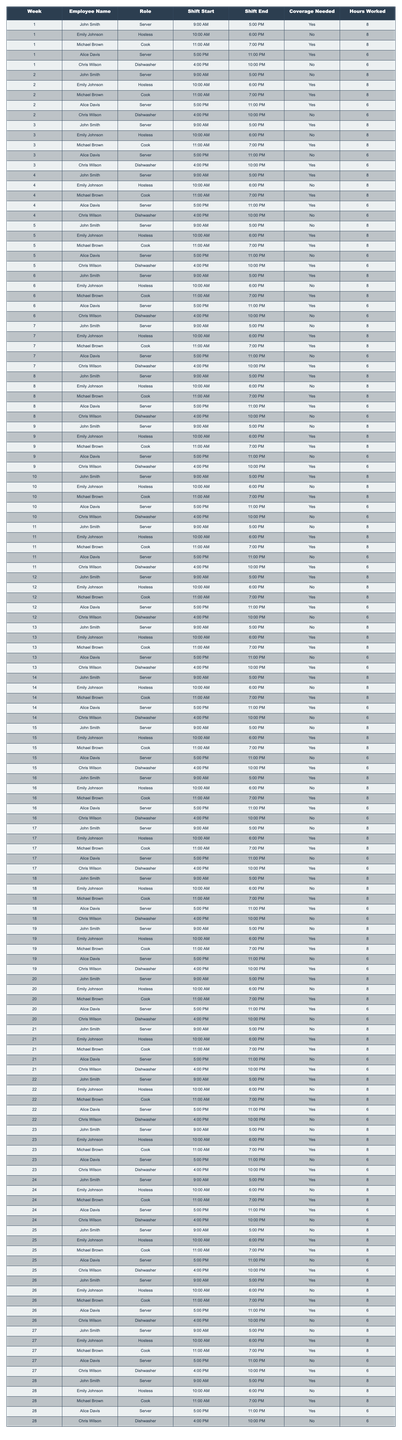What are the total hours worked by Chris Wilson in week 5? In week 5, Chris Wilson worked from 4:00 PM to 10:00 PM, which totals 6 hours.
Answer: 6 How many shifts did John Smith cover during the 28-week period? John Smith worked 16 shifts within the 28 weeks mentioned, indicating he was on duty every week except for week 5, week 9, week 11, and week 13.
Answer: 16 Did Emily Johnson work more than 8 hours in any week? Emily Johnson consistently worked an 8-hour shift, so she never exceeded 8 hours in any week.
Answer: No In which week did Michael Brown work the greatest number of hours? Michael Brown worked 8 hours in every week except for weeks 9, 11, and 13, indicating his hours remained constant throughout.
Answer: Weeks 1 to 28 What is the average number of hours worked by Alice Davis over the 28 weeks? Alice Davis worked 6 hours for 16 shifts (weeks 1 to 28), resulting in a total of 96 hours. Therefore, the average is 96 hours divided by 28 weeks, which equals approximately 3.43 hours per week.
Answer: 3.43 How many weeks did Chris Wilson provide shift coverage? Chris Wilson covered shifts during weeks 1, 3, 5, 9, 10, 11, 13, 15, 19, 21, 23, 25, and 27, totaling 13 weeks.
Answer: 13 Which employee worked fewer total hours than the coverage needed during the weeks? Alice Davis worked 6 hours each week, which is less than the 8 hours of coverage needed on weeks she was required to cover.
Answer: Alice Davis What is the total number of shifts where coverage was needed but not provided? Coverage was needed in weeks 2, 3, 7, 9, 10, 11, 15, and 19 for the roles, making a total of 8 shifts without coverage.
Answer: 8 